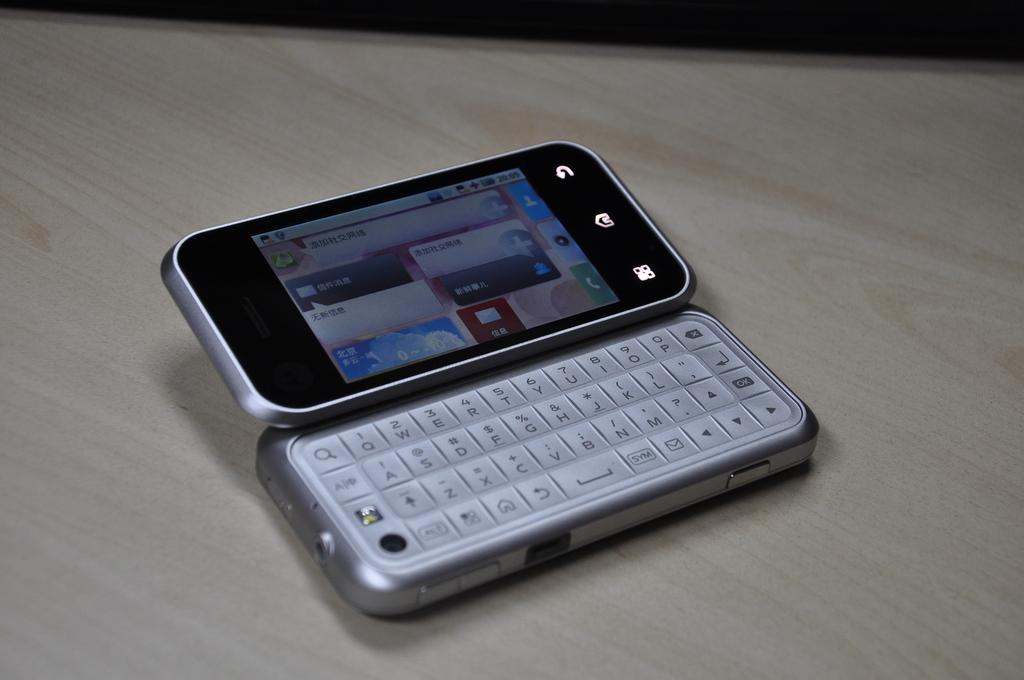What is the button to the right of the space bar?
Your answer should be very brief. Sym. 